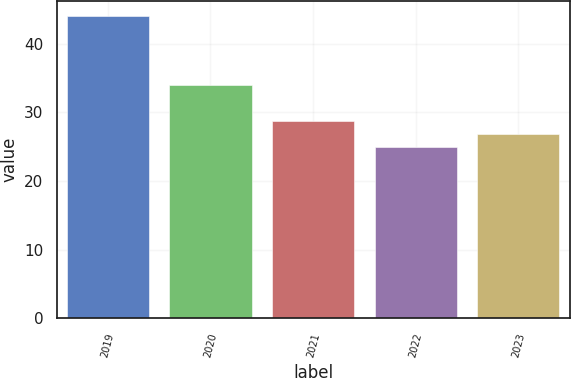Convert chart to OTSL. <chart><loc_0><loc_0><loc_500><loc_500><bar_chart><fcel>2019<fcel>2020<fcel>2021<fcel>2022<fcel>2023<nl><fcel>44<fcel>34<fcel>28.8<fcel>25<fcel>26.9<nl></chart> 